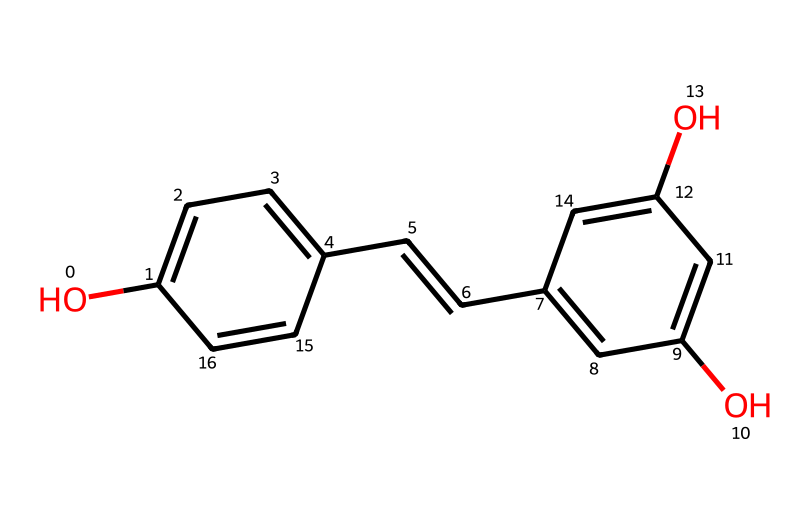What is the total number of carbon atoms in resveratrol? By analyzing the SMILES representation, we can count the carbon atoms present. Each "c" represents a carbon in an aromatic ring and "C" represents a carbon in a non-aromatic context. In the given structure, there are a total of 14 carbon atoms.
Answer: 14 How many hydroxyl (–OH) groups are present in resveratrol? In the SMILES, each "O" corresponds to an oxygen atom, and when attached to a carbon in this context, it forms a hydroxyl group. The structure features three "O" characters, indicating three hydroxyl groups.
Answer: 3 What kind of chemical structure does resveratrol depict? The structure contains multiple aromatic rings and unsaturated bonds, suggesting that resveratrol is a polyphenol compound. The presence of hydroxyl groups further supports this classification.
Answer: polyphenol Which part of the chemical structure contributes to its antioxidant properties? The hydroxyl groups present in the structure are known to donate hydrogen atoms, which helps in neutralizing free radicals, thereby contributing to the antioxidant properties. This is a significant feature in the chemical's function.
Answer: hydroxyl groups Is resveratrol a simple or complex molecule? By examining the interconnected rings, double bonds, and presence of functional groups, we can determine that resveratrol has a relatively complex structure compared to simple organic molecules like alkanes.
Answer: complex How many double bonds are present in resveratrol? Observing the structure carefully, we find that there are two double bonds in the carbon chain, which can be identified by the “C=C” in the SMILES representation.
Answer: 2 